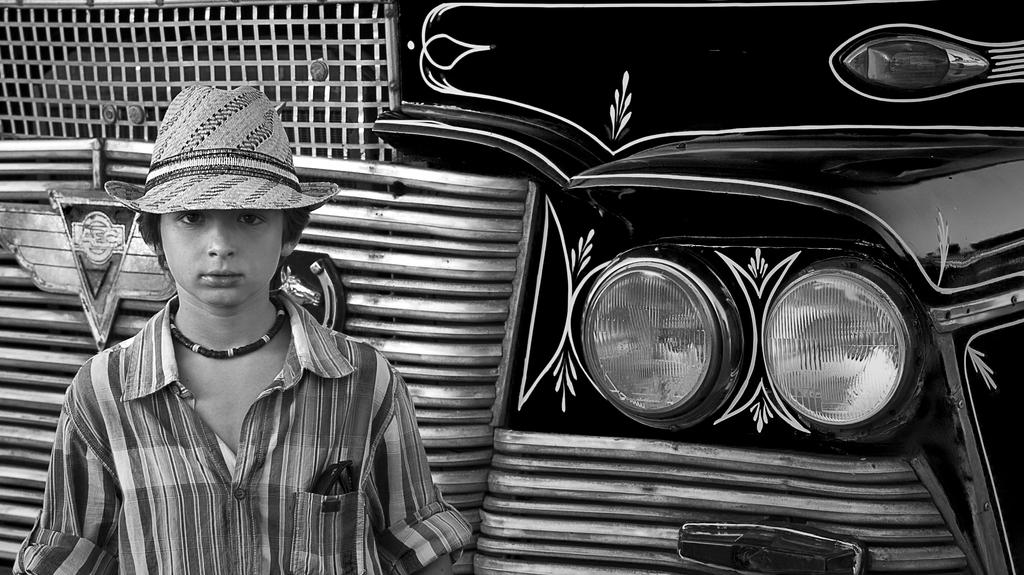What is the main subject in the foreground of the image? There is a boy in the foreground of the image. What is the boy wearing on his head? The boy is wearing a hat. What else can be seen in the foreground of the image? There is a vehicle in the foreground of the image. Can you determine the time of day when the image was taken? The image was likely taken during the day, as there is no indication of darkness or artificial lighting. What type of farm animals can be seen playing with toys in the image? There is no farm or toys present in the image; it features a boy and a vehicle in the foreground. 